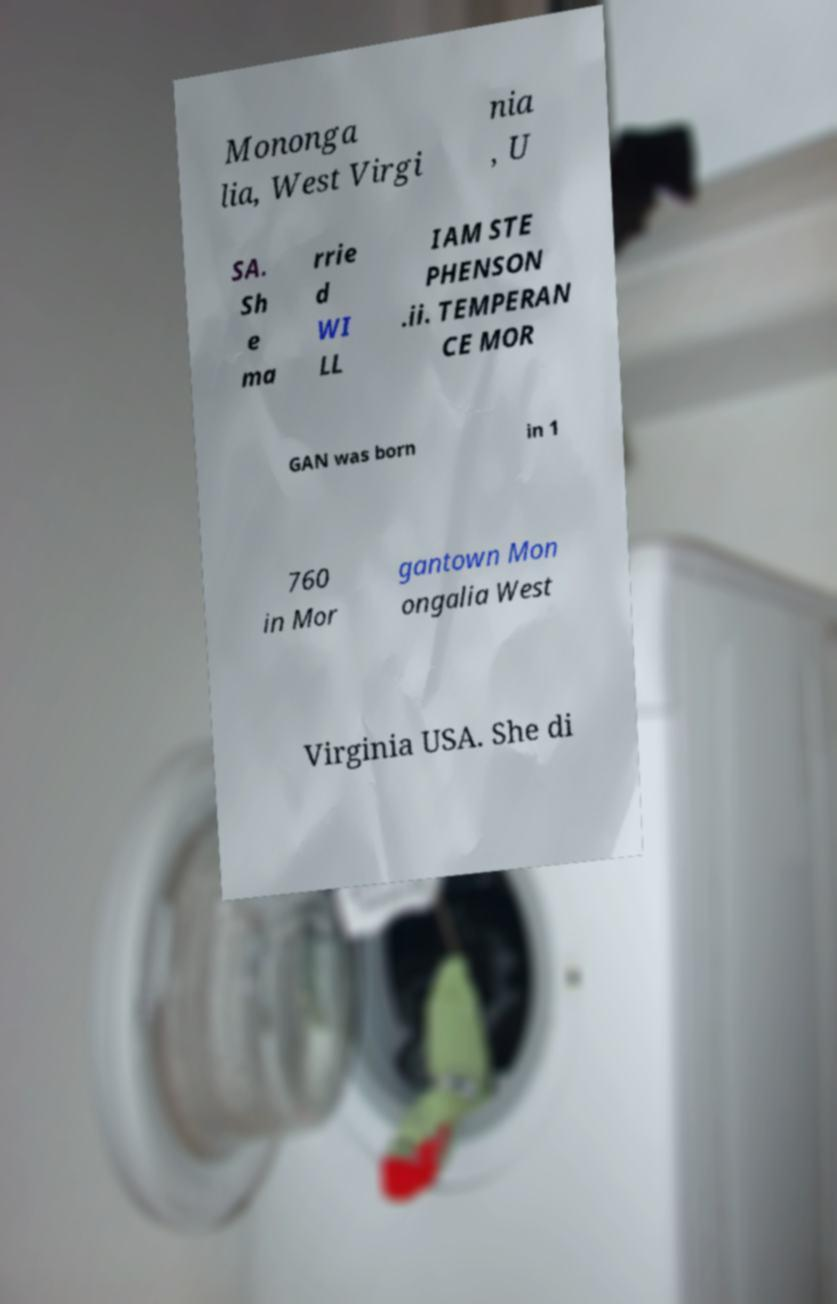Could you assist in decoding the text presented in this image and type it out clearly? Mononga lia, West Virgi nia , U SA. Sh e ma rrie d WI LL IAM STE PHENSON .ii. TEMPERAN CE MOR GAN was born in 1 760 in Mor gantown Mon ongalia West Virginia USA. She di 